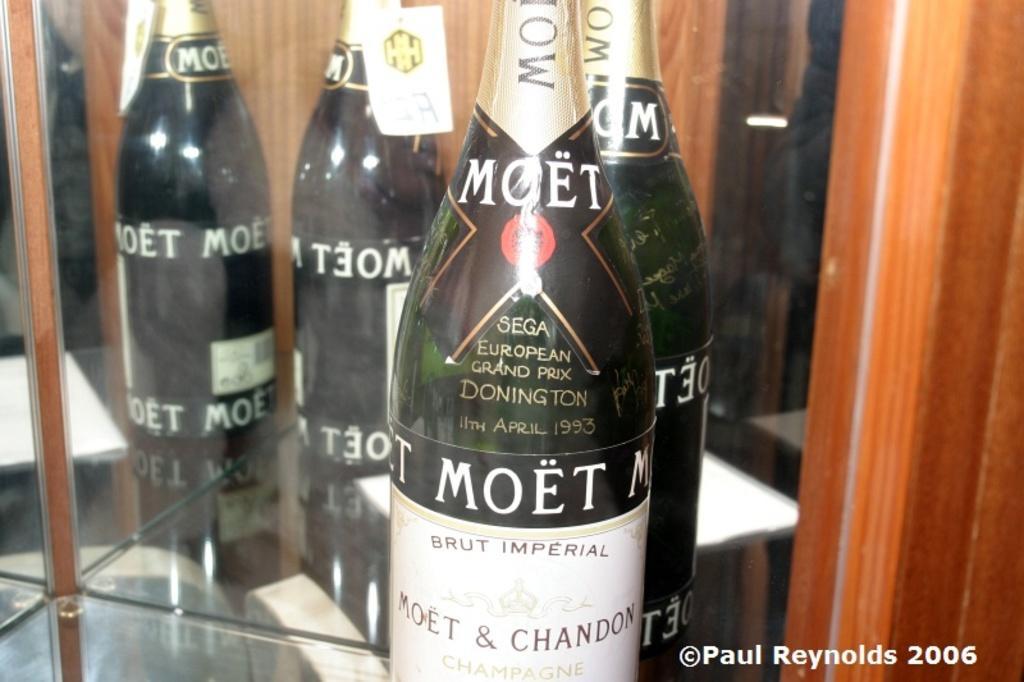In one or two sentences, can you explain what this image depicts? Here we can see a bottle with sticker and text. Background we can see glass and wooden object. Through the glass we can see few bottles are placed on the glass surface. Right side bottom of the image, we can see watermark. 